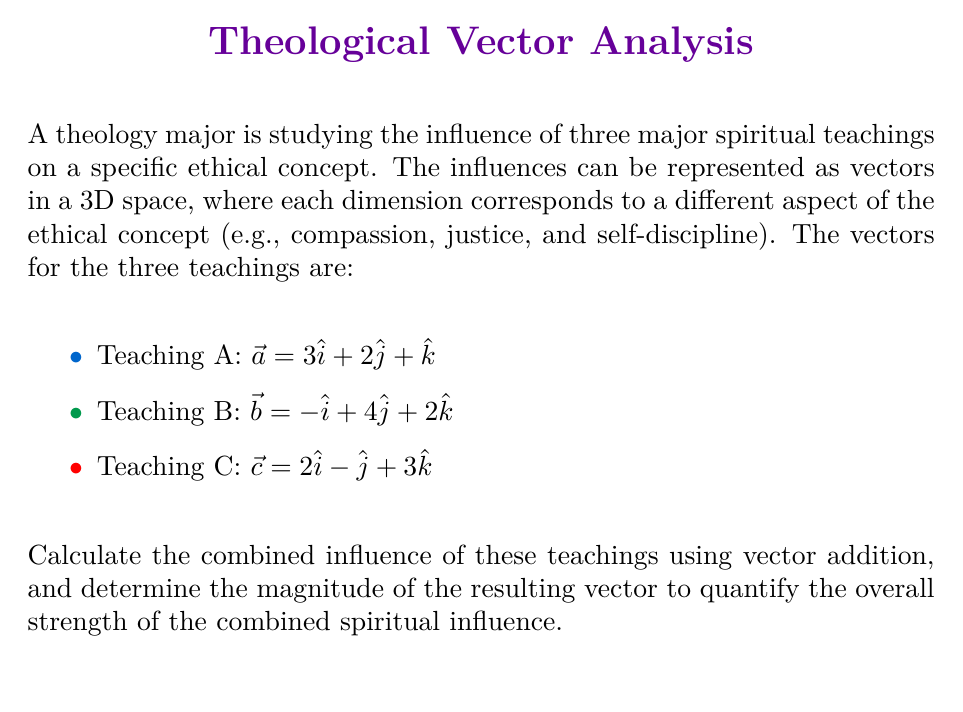Could you help me with this problem? Let's approach this step-by-step:

1) To combine the influences, we need to add the three vectors:

   $\vec{r} = \vec{a} + \vec{b} + \vec{c}$

2) Let's substitute the given vectors:

   $\vec{r} = (3\hat{i} + 2\hat{j} + \hat{k}) + (-\hat{i} + 4\hat{j} + 2\hat{k}) + (2\hat{i} - \hat{j} + 3\hat{k})$

3) Now, let's add the components:

   $\vec{r} = (3-1+2)\hat{i} + (2+4-1)\hat{j} + (1+2+3)\hat{k}$

4) Simplifying:

   $\vec{r} = 4\hat{i} + 5\hat{j} + 6\hat{k}$

5) To find the magnitude of this resultant vector, we use the formula:

   $|\vec{r}| = \sqrt{x^2 + y^2 + z^2}$

   Where x, y, and z are the components of the vector.

6) Substituting our values:

   $|\vec{r}| = \sqrt{4^2 + 5^2 + 6^2}$

7) Calculating:

   $|\vec{r}| = \sqrt{16 + 25 + 36} = \sqrt{77}$

8) Simplifying:

   $|\vec{r}| = \sqrt{77} \approx 8.775$

Thus, the combined influence is represented by the vector $4\hat{i} + 5\hat{j} + 6\hat{k}$, with a magnitude of $\sqrt{77}$ or approximately 8.775 units.
Answer: $\vec{r} = 4\hat{i} + 5\hat{j} + 6\hat{k}$, $|\vec{r}| = \sqrt{77} \approx 8.775$ 